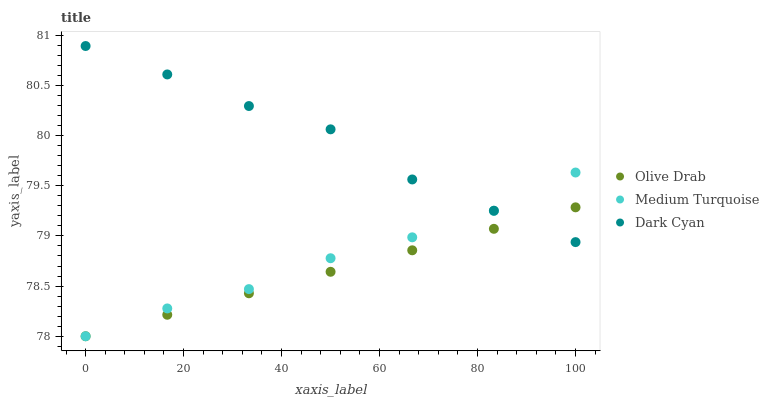Does Olive Drab have the minimum area under the curve?
Answer yes or no. Yes. Does Dark Cyan have the maximum area under the curve?
Answer yes or no. Yes. Does Medium Turquoise have the minimum area under the curve?
Answer yes or no. No. Does Medium Turquoise have the maximum area under the curve?
Answer yes or no. No. Is Olive Drab the smoothest?
Answer yes or no. Yes. Is Dark Cyan the roughest?
Answer yes or no. Yes. Is Medium Turquoise the smoothest?
Answer yes or no. No. Is Medium Turquoise the roughest?
Answer yes or no. No. Does Medium Turquoise have the lowest value?
Answer yes or no. Yes. Does Dark Cyan have the highest value?
Answer yes or no. Yes. Does Medium Turquoise have the highest value?
Answer yes or no. No. Does Olive Drab intersect Dark Cyan?
Answer yes or no. Yes. Is Olive Drab less than Dark Cyan?
Answer yes or no. No. Is Olive Drab greater than Dark Cyan?
Answer yes or no. No. 